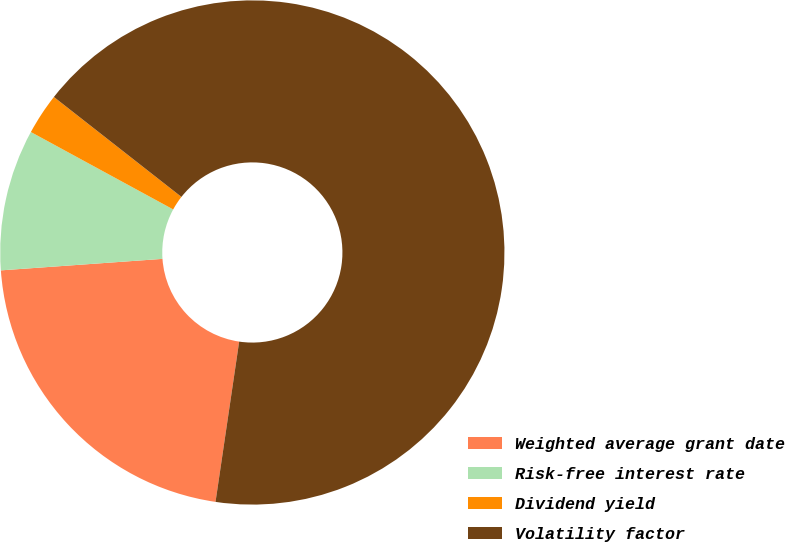<chart> <loc_0><loc_0><loc_500><loc_500><pie_chart><fcel>Weighted average grant date<fcel>Risk-free interest rate<fcel>Dividend yield<fcel>Volatility factor<nl><fcel>21.54%<fcel>9.06%<fcel>2.65%<fcel>66.76%<nl></chart> 